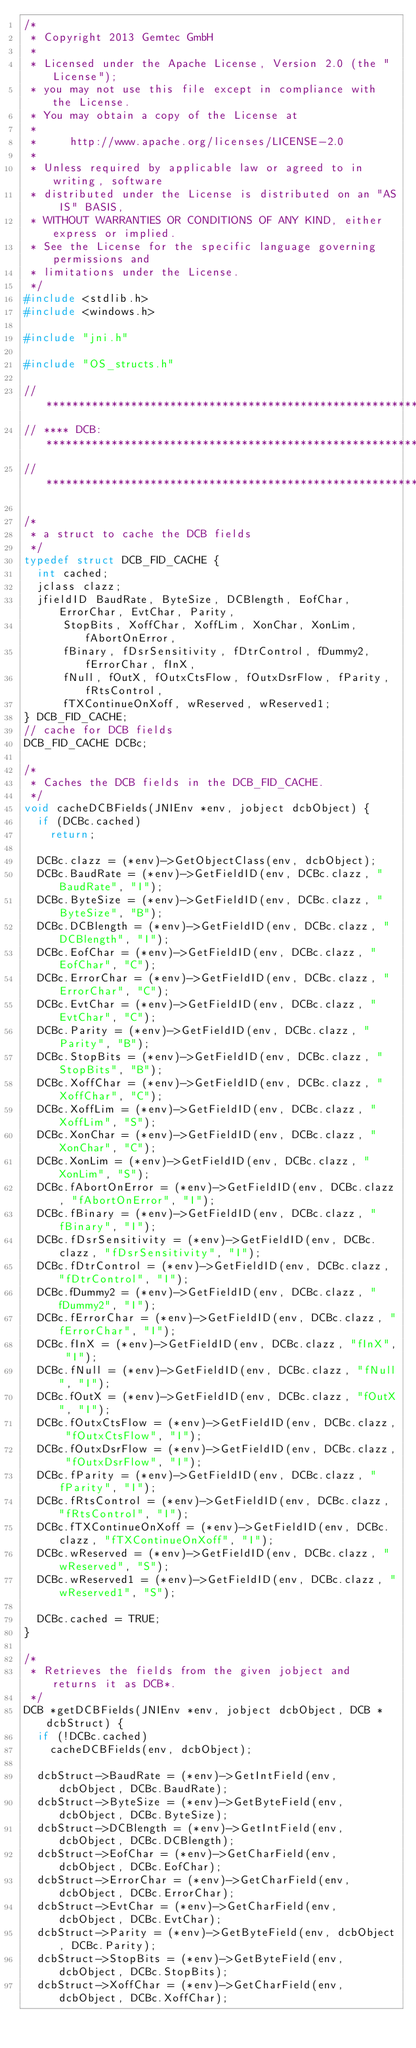Convert code to text. <code><loc_0><loc_0><loc_500><loc_500><_C_>/*
 * Copyright 2013 Gemtec GmbH
 *
 * Licensed under the Apache License, Version 2.0 (the "License");
 * you may not use this file except in compliance with the License.
 * You may obtain a copy of the License at
 *
 *     http://www.apache.org/licenses/LICENSE-2.0
 *
 * Unless required by applicable law or agreed to in writing, software
 * distributed under the License is distributed on an "AS IS" BASIS,
 * WITHOUT WARRANTIES OR CONDITIONS OF ANY KIND, either express or implied.
 * See the License for the specific language governing permissions and
 * limitations under the License.
 */
#include <stdlib.h>
#include <windows.h>

#include "jni.h"

#include "OS_structs.h"

// ***********************************************************************
// **** DCB: *************************************************************
// ***********************************************************************

/*
 * a struct to cache the DCB fields
 */
typedef struct DCB_FID_CACHE {
	int cached;
	jclass clazz;
	jfieldID BaudRate, ByteSize, DCBlength, EofChar, ErrorChar, EvtChar, Parity,
			StopBits, XoffChar, XoffLim, XonChar, XonLim, fAbortOnError,
			fBinary, fDsrSensitivity, fDtrControl, fDummy2, fErrorChar, fInX,
			fNull, fOutX, fOutxCtsFlow, fOutxDsrFlow, fParity, fRtsControl,
			fTXContinueOnXoff, wReserved, wReserved1;
} DCB_FID_CACHE;
// cache for DCB fields
DCB_FID_CACHE DCBc;

/*
 * Caches the DCB fields in the DCB_FID_CACHE.
 */
void cacheDCBFields(JNIEnv *env, jobject dcbObject) {
	if (DCBc.cached)
		return;

	DCBc.clazz = (*env)->GetObjectClass(env, dcbObject);
	DCBc.BaudRate = (*env)->GetFieldID(env, DCBc.clazz, "BaudRate", "I");
	DCBc.ByteSize = (*env)->GetFieldID(env, DCBc.clazz, "ByteSize", "B");
	DCBc.DCBlength = (*env)->GetFieldID(env, DCBc.clazz, "DCBlength", "I");
	DCBc.EofChar = (*env)->GetFieldID(env, DCBc.clazz, "EofChar", "C");
	DCBc.ErrorChar = (*env)->GetFieldID(env, DCBc.clazz, "ErrorChar", "C");
	DCBc.EvtChar = (*env)->GetFieldID(env, DCBc.clazz, "EvtChar", "C");
	DCBc.Parity = (*env)->GetFieldID(env, DCBc.clazz, "Parity", "B");
	DCBc.StopBits = (*env)->GetFieldID(env, DCBc.clazz, "StopBits", "B");
	DCBc.XoffChar = (*env)->GetFieldID(env, DCBc.clazz, "XoffChar", "C");
	DCBc.XoffLim = (*env)->GetFieldID(env, DCBc.clazz, "XoffLim", "S");
	DCBc.XonChar = (*env)->GetFieldID(env, DCBc.clazz, "XonChar", "C");
	DCBc.XonLim = (*env)->GetFieldID(env, DCBc.clazz, "XonLim", "S");
	DCBc.fAbortOnError = (*env)->GetFieldID(env, DCBc.clazz, "fAbortOnError", "I");
	DCBc.fBinary = (*env)->GetFieldID(env, DCBc.clazz, "fBinary", "I");
	DCBc.fDsrSensitivity = (*env)->GetFieldID(env, DCBc.clazz, "fDsrSensitivity", "I");
	DCBc.fDtrControl = (*env)->GetFieldID(env, DCBc.clazz, "fDtrControl", "I");
	DCBc.fDummy2 = (*env)->GetFieldID(env, DCBc.clazz, "fDummy2", "I");
	DCBc.fErrorChar = (*env)->GetFieldID(env, DCBc.clazz, "fErrorChar", "I");
	DCBc.fInX = (*env)->GetFieldID(env, DCBc.clazz, "fInX", "I");
	DCBc.fNull = (*env)->GetFieldID(env, DCBc.clazz, "fNull", "I");
	DCBc.fOutX = (*env)->GetFieldID(env, DCBc.clazz, "fOutX", "I");
	DCBc.fOutxCtsFlow = (*env)->GetFieldID(env, DCBc.clazz, "fOutxCtsFlow", "I");
	DCBc.fOutxDsrFlow = (*env)->GetFieldID(env, DCBc.clazz, "fOutxDsrFlow",	"I");
	DCBc.fParity = (*env)->GetFieldID(env, DCBc.clazz, "fParity", "I");
	DCBc.fRtsControl = (*env)->GetFieldID(env, DCBc.clazz, "fRtsControl", "I");
	DCBc.fTXContinueOnXoff = (*env)->GetFieldID(env, DCBc.clazz, "fTXContinueOnXoff", "I");
	DCBc.wReserved = (*env)->GetFieldID(env, DCBc.clazz, "wReserved", "S");
	DCBc.wReserved1 = (*env)->GetFieldID(env, DCBc.clazz, "wReserved1", "S");

	DCBc.cached = TRUE;
}

/*
 * Retrieves the fields from the given jobject and returns it as DCB*.
 */
DCB *getDCBFields(JNIEnv *env, jobject dcbObject, DCB *dcbStruct) {
	if (!DCBc.cached)
		cacheDCBFields(env, dcbObject);

	dcbStruct->BaudRate = (*env)->GetIntField(env, dcbObject, DCBc.BaudRate);
	dcbStruct->ByteSize = (*env)->GetByteField(env, dcbObject, DCBc.ByteSize);
	dcbStruct->DCBlength = (*env)->GetIntField(env, dcbObject, DCBc.DCBlength);
	dcbStruct->EofChar = (*env)->GetCharField(env, dcbObject, DCBc.EofChar);
	dcbStruct->ErrorChar = (*env)->GetCharField(env, dcbObject, DCBc.ErrorChar);
	dcbStruct->EvtChar = (*env)->GetCharField(env, dcbObject, DCBc.EvtChar);
	dcbStruct->Parity = (*env)->GetByteField(env, dcbObject, DCBc.Parity);
	dcbStruct->StopBits = (*env)->GetByteField(env, dcbObject, DCBc.StopBits);
	dcbStruct->XoffChar = (*env)->GetCharField(env, dcbObject, DCBc.XoffChar);</code> 